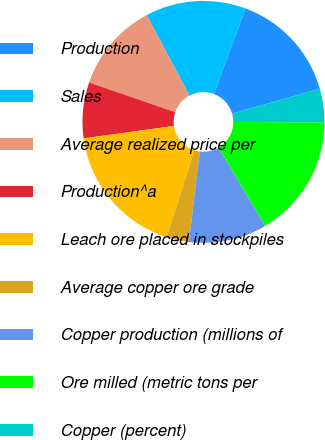Convert chart. <chart><loc_0><loc_0><loc_500><loc_500><pie_chart><fcel>Production<fcel>Sales<fcel>Average realized price per<fcel>Production^a<fcel>Leach ore placed in stockpiles<fcel>Average copper ore grade<fcel>Copper production (millions of<fcel>Ore milled (metric tons per<fcel>Copper (percent)<nl><fcel>14.93%<fcel>13.43%<fcel>11.94%<fcel>7.46%<fcel>17.91%<fcel>2.99%<fcel>10.45%<fcel>16.42%<fcel>4.48%<nl></chart> 